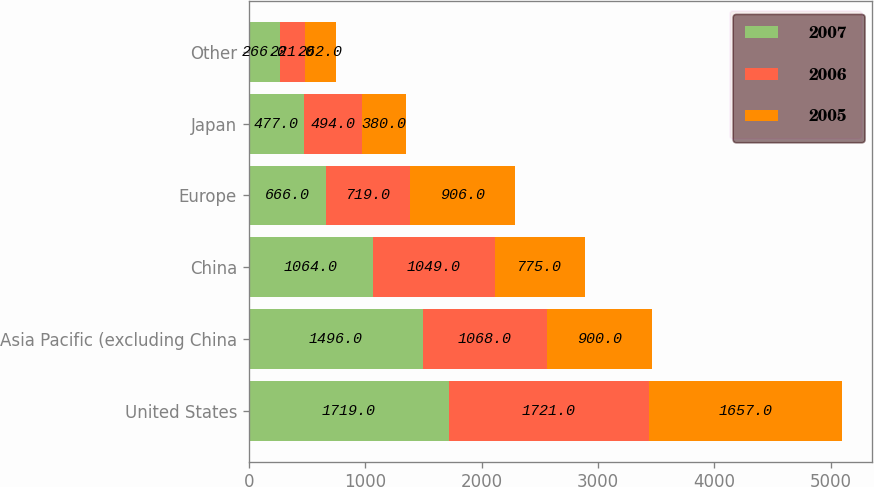Convert chart. <chart><loc_0><loc_0><loc_500><loc_500><stacked_bar_chart><ecel><fcel>United States<fcel>Asia Pacific (excluding China<fcel>China<fcel>Europe<fcel>Japan<fcel>Other<nl><fcel>2007<fcel>1719<fcel>1496<fcel>1064<fcel>666<fcel>477<fcel>266<nl><fcel>2006<fcel>1721<fcel>1068<fcel>1049<fcel>719<fcel>494<fcel>221<nl><fcel>2005<fcel>1657<fcel>900<fcel>775<fcel>906<fcel>380<fcel>262<nl></chart> 